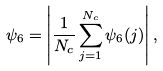Convert formula to latex. <formula><loc_0><loc_0><loc_500><loc_500>\psi _ { 6 } = \left | \frac { 1 } { N _ { c } } \sum _ { j = 1 } ^ { N _ { c } } \psi _ { 6 } ( j ) \right | ,</formula> 